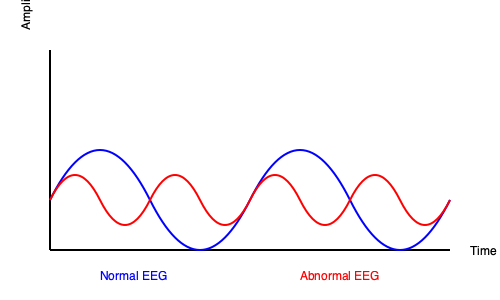Analyze the EEG waveforms presented in the graph. Which neuropsychiatric disorder is most likely associated with the abnormal (red) EEG pattern, and what specific features of this waveform support your diagnosis? To analyze the EEG waveforms and identify the associated neuropsychiatric disorder, we need to follow these steps:

1. Observe the normal EEG pattern (blue):
   - Regular, sinusoidal waves
   - Consistent amplitude and frequency
   - Smooth transitions between peaks and troughs

2. Analyze the abnormal EEG pattern (red):
   - Sharp, repetitive spikes
   - Higher frequency compared to the normal EEG
   - Reduced amplitude
   - Lack of smooth wave transitions

3. Compare the abnormal pattern to known EEG characteristics of neuropsychiatric disorders:
   - The sharp, repetitive spikes are characteristic of epileptiform activity
   - The higher frequency and reduced amplitude suggest increased cortical excitability
   - The lack of smooth transitions indicates disrupted normal brain rhythms

4. Match the observed features to specific disorders:
   - Epilepsy is characterized by recurrent seizures and abnormal, excessive, or synchronous neuronal activity in the brain
   - The EEG pattern shown is consistent with interictal epileptiform discharges (IEDs)

5. Consider additional features:
   - The regularity and persistence of the spike pattern suggest a chronic condition
   - The widespread nature of the abnormal activity (across the entire displayed EEG) indicates a generalized epilepsy rather than a focal type

Based on these observations and analysis, the neuropsychiatric disorder most likely associated with the abnormal (red) EEG pattern is generalized epilepsy. The specific features supporting this diagnosis are the sharp, repetitive spikes (epileptiform discharges), increased frequency, reduced amplitude, and the generalized nature of the abnormal activity across the EEG.
Answer: Generalized epilepsy, evidenced by sharp repetitive spikes, increased frequency, and reduced amplitude. 